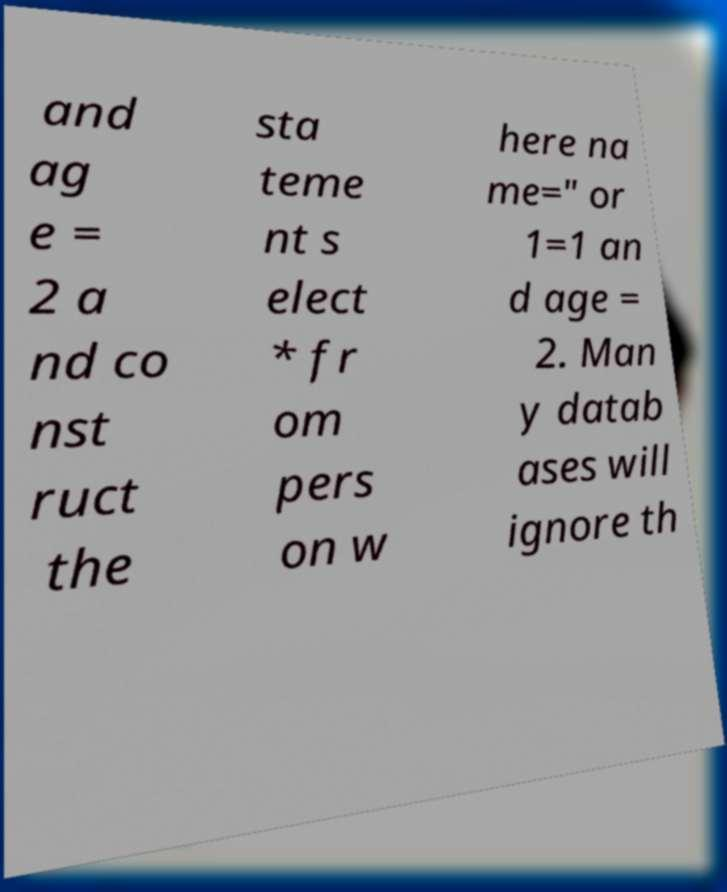There's text embedded in this image that I need extracted. Can you transcribe it verbatim? and ag e = 2 a nd co nst ruct the sta teme nt s elect * fr om pers on w here na me=" or 1=1 an d age = 2. Man y datab ases will ignore th 